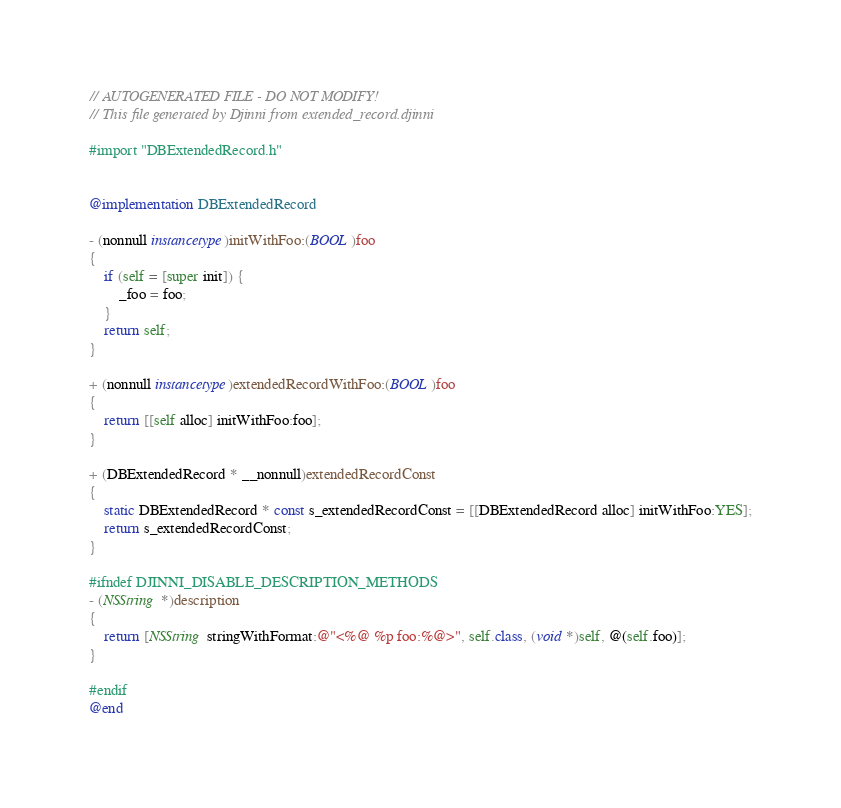<code> <loc_0><loc_0><loc_500><loc_500><_ObjectiveC_>// AUTOGENERATED FILE - DO NOT MODIFY!
// This file generated by Djinni from extended_record.djinni

#import "DBExtendedRecord.h"


@implementation DBExtendedRecord

- (nonnull instancetype)initWithFoo:(BOOL)foo
{
    if (self = [super init]) {
        _foo = foo;
    }
    return self;
}

+ (nonnull instancetype)extendedRecordWithFoo:(BOOL)foo
{
    return [[self alloc] initWithFoo:foo];
}

+ (DBExtendedRecord * __nonnull)extendedRecordConst
{
    static DBExtendedRecord * const s_extendedRecordConst = [[DBExtendedRecord alloc] initWithFoo:YES];
    return s_extendedRecordConst;
}

#ifndef DJINNI_DISABLE_DESCRIPTION_METHODS
- (NSString *)description
{
    return [NSString stringWithFormat:@"<%@ %p foo:%@>", self.class, (void *)self, @(self.foo)];
}

#endif
@end
</code> 